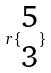Convert formula to latex. <formula><loc_0><loc_0><loc_500><loc_500>r \{ \begin{matrix} 5 \\ 3 \end{matrix} \}</formula> 